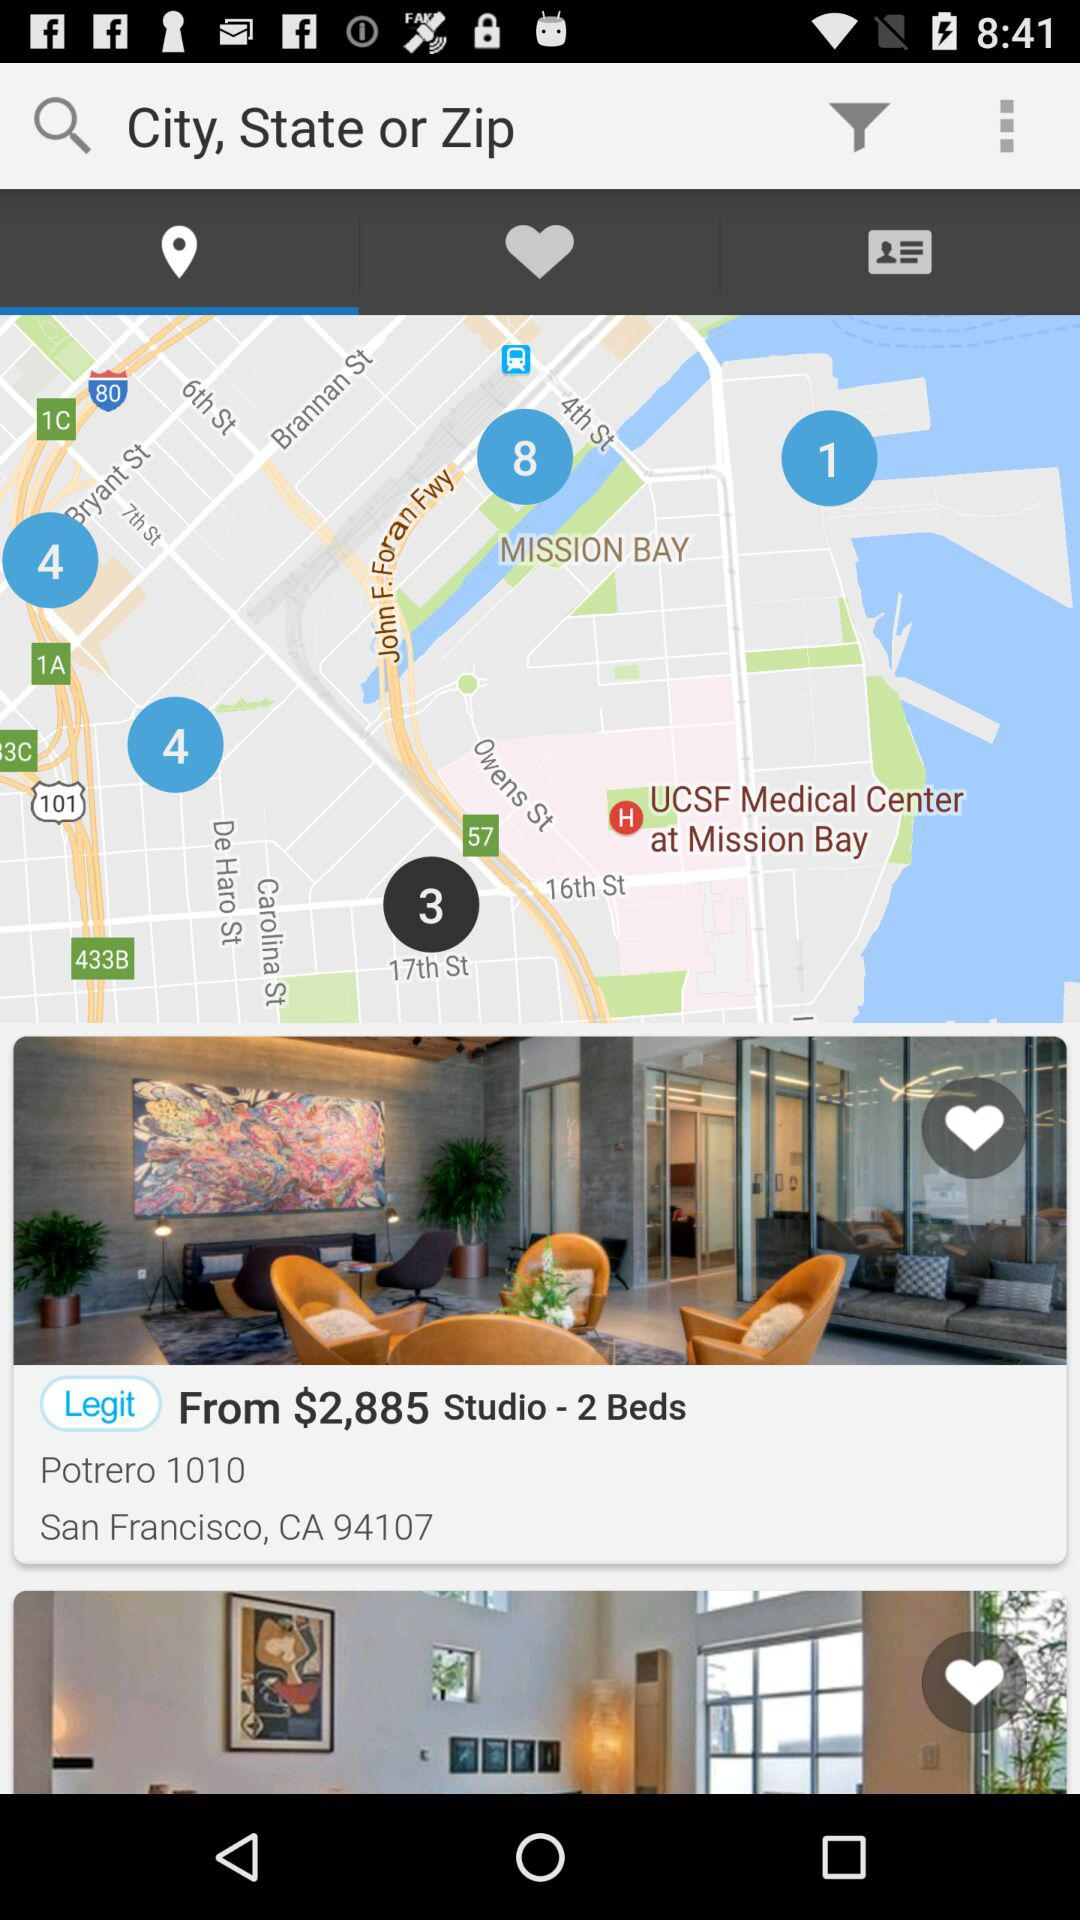Where is "Potrero 1010" located? "Potrero 1010" is located in San Francisco, CA 94107. 